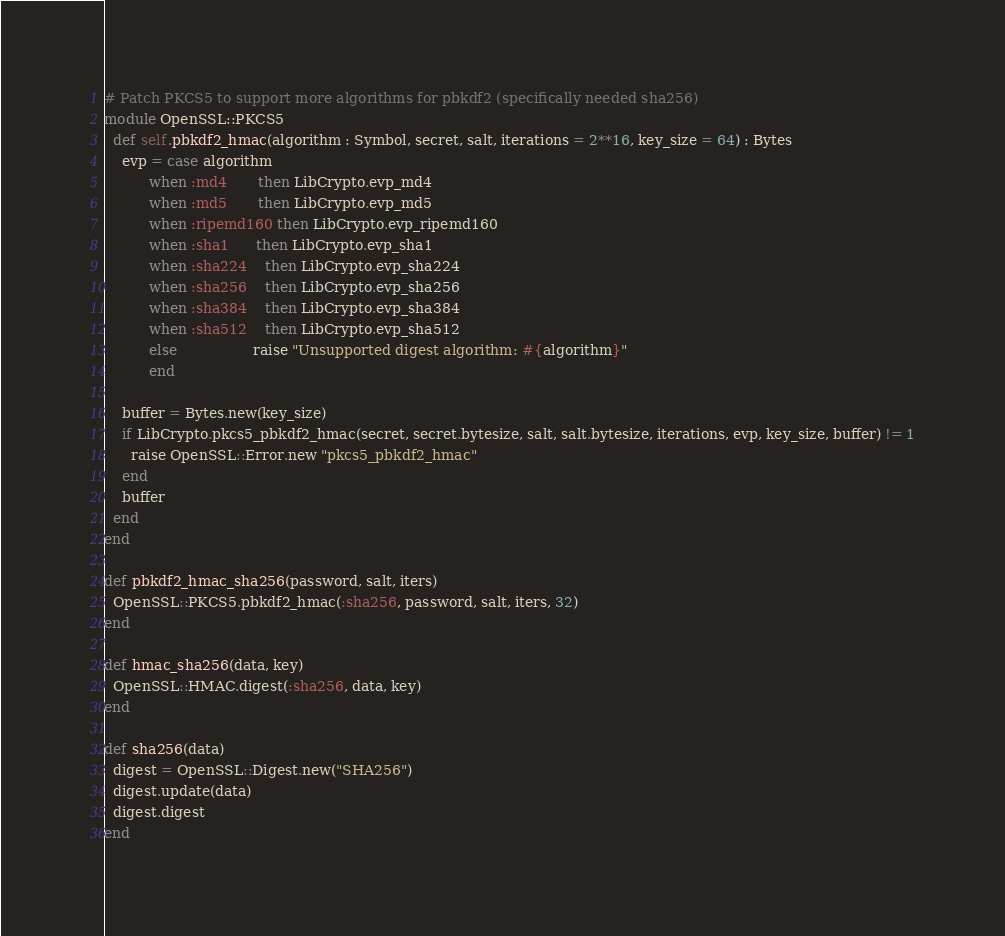Convert code to text. <code><loc_0><loc_0><loc_500><loc_500><_Crystal_>
# Patch PKCS5 to support more algorithms for pbkdf2 (specifically needed sha256)
module OpenSSL::PKCS5
  def self.pbkdf2_hmac(algorithm : Symbol, secret, salt, iterations = 2**16, key_size = 64) : Bytes
    evp = case algorithm
          when :md4       then LibCrypto.evp_md4
          when :md5       then LibCrypto.evp_md5
          when :ripemd160 then LibCrypto.evp_ripemd160
          when :sha1      then LibCrypto.evp_sha1
          when :sha224    then LibCrypto.evp_sha224
          when :sha256    then LibCrypto.evp_sha256
          when :sha384    then LibCrypto.evp_sha384
          when :sha512    then LibCrypto.evp_sha512
          else                 raise "Unsupported digest algorithm: #{algorithm}"
          end

    buffer = Bytes.new(key_size)
    if LibCrypto.pkcs5_pbkdf2_hmac(secret, secret.bytesize, salt, salt.bytesize, iterations, evp, key_size, buffer) != 1
      raise OpenSSL::Error.new "pkcs5_pbkdf2_hmac"
    end
    buffer
  end
end

def pbkdf2_hmac_sha256(password, salt, iters)
  OpenSSL::PKCS5.pbkdf2_hmac(:sha256, password, salt, iters, 32)
end

def hmac_sha256(data, key)
  OpenSSL::HMAC.digest(:sha256, data, key)
end

def sha256(data)
  digest = OpenSSL::Digest.new("SHA256")
  digest.update(data)
  digest.digest
end
</code> 